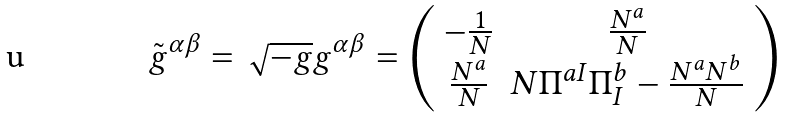<formula> <loc_0><loc_0><loc_500><loc_500>\tilde { g } ^ { \alpha \beta } = \sqrt { - g } g ^ { \alpha \beta } = \left ( \begin{array} { c c } - \frac { 1 } { N } & \frac { N ^ { a } } { N } \\ \frac { N ^ { a } } { N } & N \Pi ^ { a I } \Pi ^ { b } _ { I } - \frac { N ^ { a } N ^ { b } } { N } \end{array} \right )</formula> 